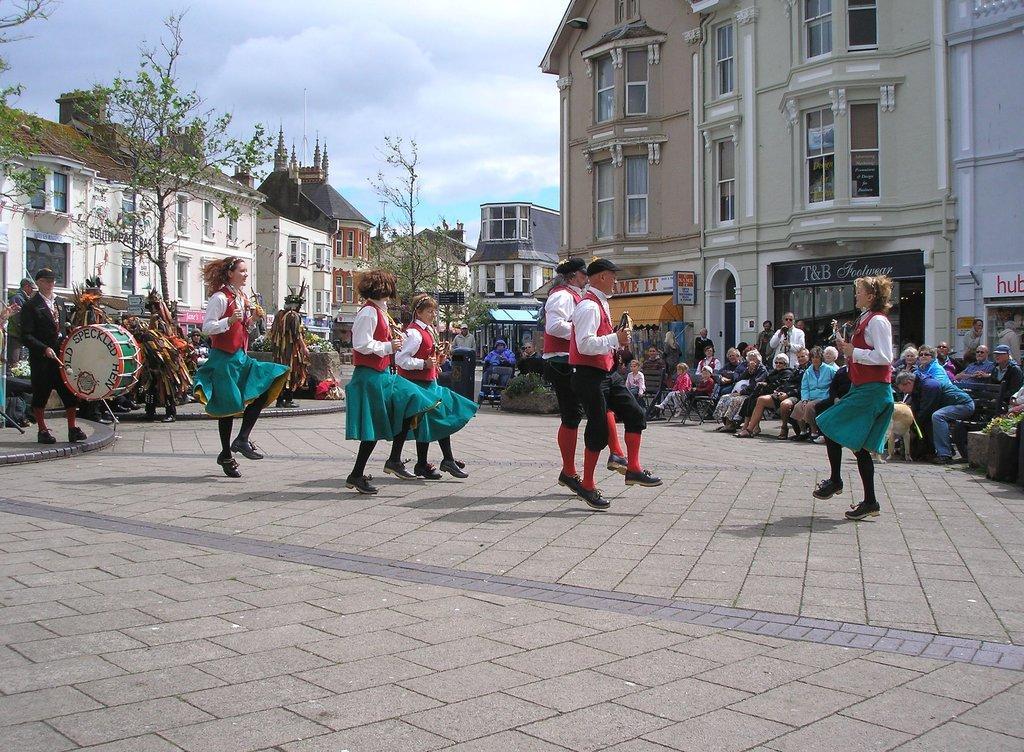In one or two sentences, can you explain what this image depicts? In the foreground of this picture, there are people dancing on the ground. On the left side of the image, there is a man playing a drum. In the background, there are audience, buildings, trees, and the sky. 